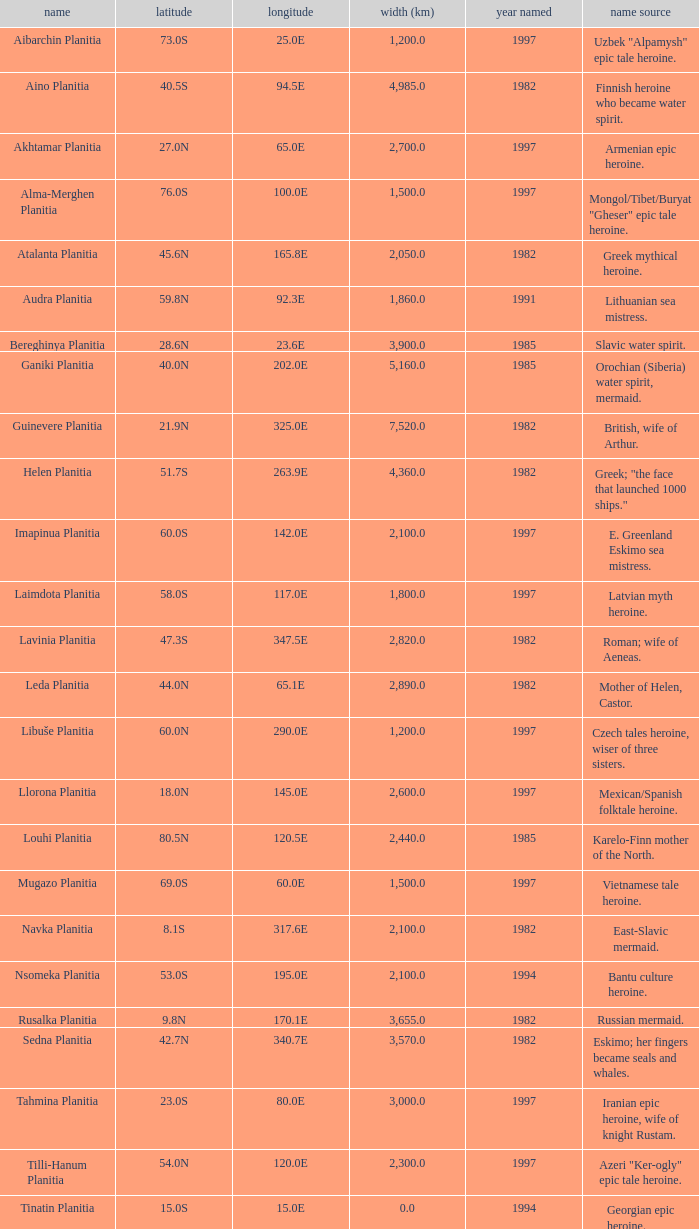What is the diameter (km) of longitude 170.1e 3655.0. 